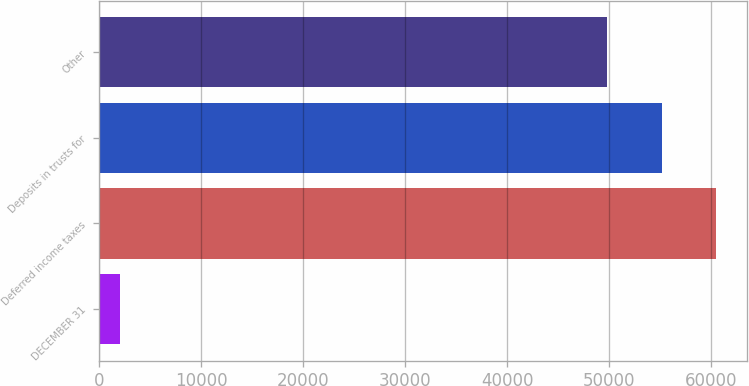Convert chart to OTSL. <chart><loc_0><loc_0><loc_500><loc_500><bar_chart><fcel>DECEMBER 31<fcel>Deferred income taxes<fcel>Deposits in trusts for<fcel>Other<nl><fcel>2007<fcel>60471<fcel>55119.5<fcel>49768<nl></chart> 